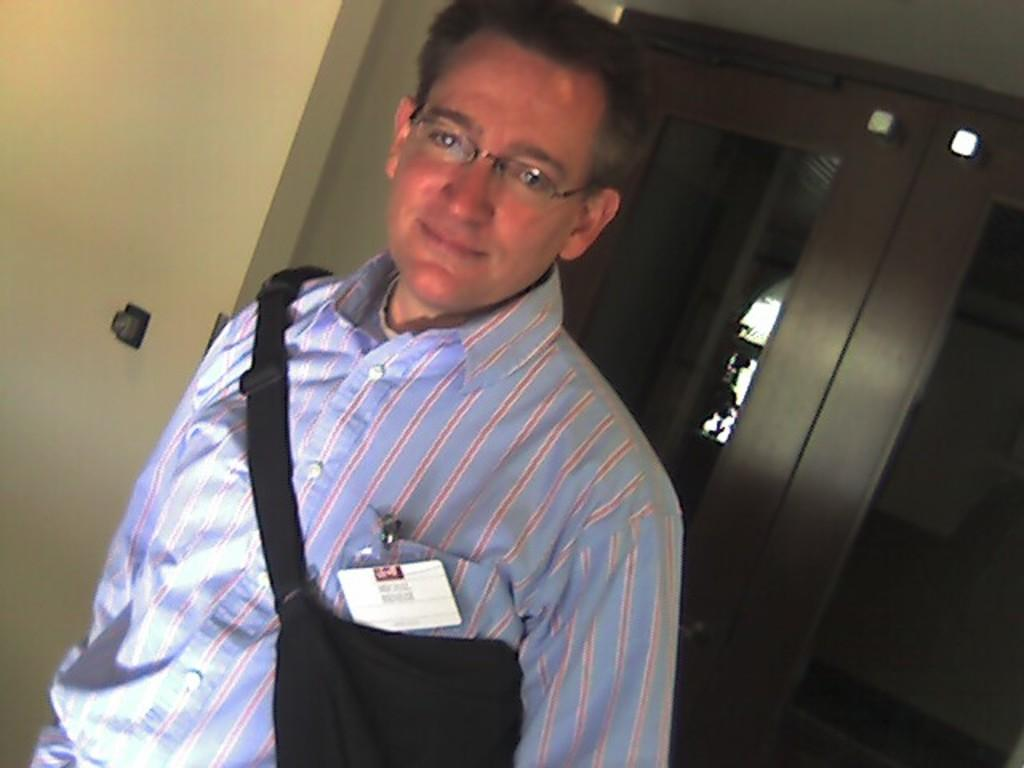Who is present in the image? There is a man in the image. What is the man wearing in the image? The man is wearing a bag in the image. What can be seen in the background of the image? There are walls and doors in the background of the image. What type of drink is the man holding in the image? There is no drink visible in the image; the man is wearing a bag. What color are the man's lips in the image? There is no information about the man's lips in the image, as the focus is on his bag and the background. 